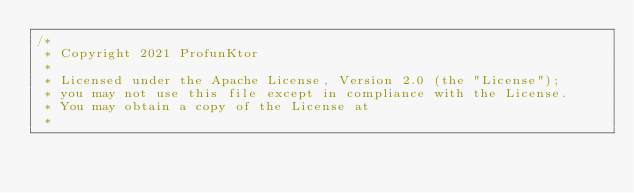<code> <loc_0><loc_0><loc_500><loc_500><_Scala_>/*
 * Copyright 2021 ProfunKtor
 *
 * Licensed under the Apache License, Version 2.0 (the "License");
 * you may not use this file except in compliance with the License.
 * You may obtain a copy of the License at
 *</code> 